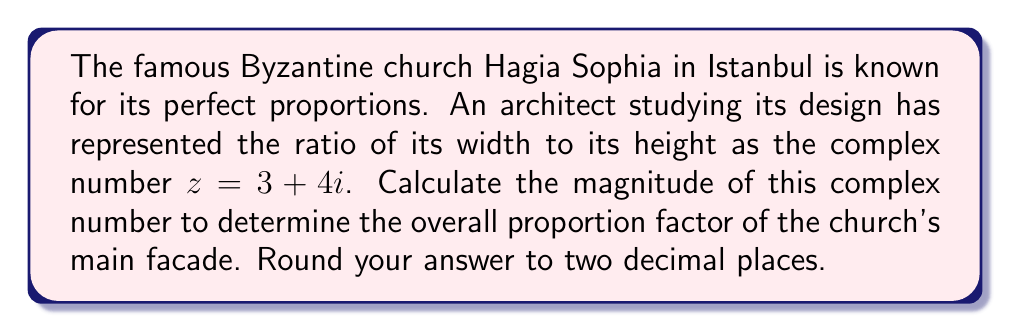Provide a solution to this math problem. To calculate the magnitude of a complex number, we use the formula:

$$|z| = \sqrt{a^2 + b^2}$$

Where $z = a + bi$ is the complex number, $a$ is the real part, and $b$ is the imaginary part.

In this case, we have $z = 3 + 4i$, so $a = 3$ and $b = 4$.

Let's substitute these values into the formula:

$$|z| = \sqrt{3^2 + 4^2}$$

Now we can calculate:

$$|z| = \sqrt{9 + 16}$$
$$|z| = \sqrt{25}$$
$$|z| = 5$$

The magnitude of the complex number is exactly 5, so we don't need to round in this case.

This result means that the overall proportion factor of Hagia Sophia's main facade, based on the width-to-height ratio represented by the complex number, is 5.
Answer: $5$ 